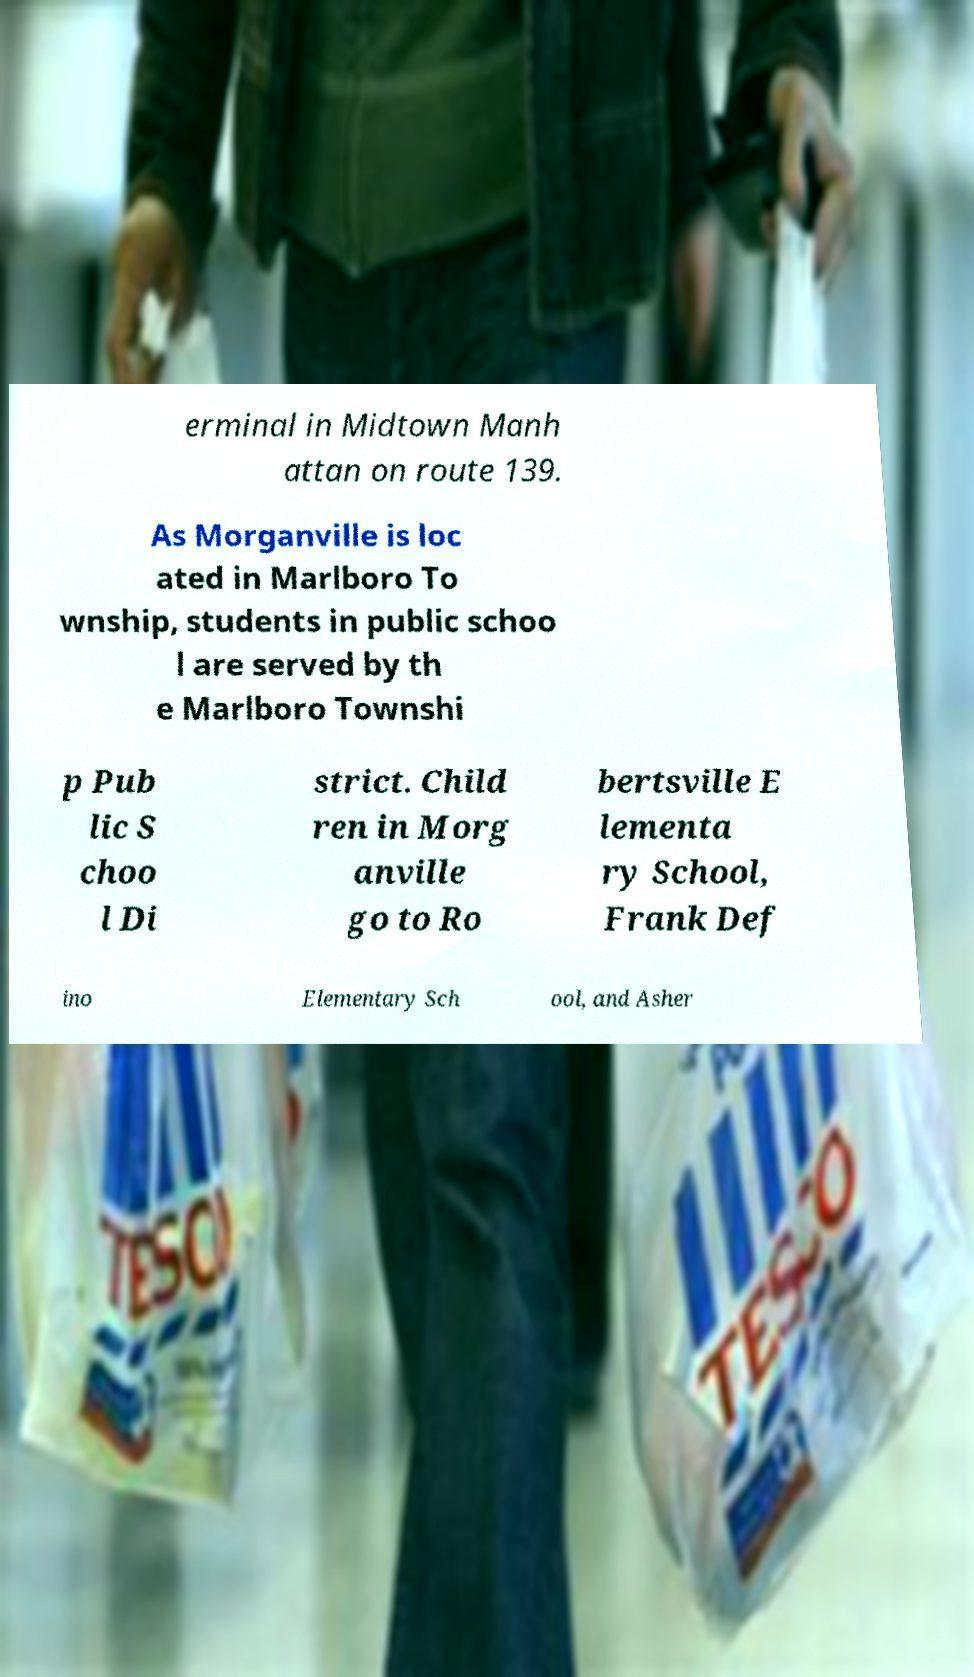Please read and relay the text visible in this image. What does it say? erminal in Midtown Manh attan on route 139. As Morganville is loc ated in Marlboro To wnship, students in public schoo l are served by th e Marlboro Townshi p Pub lic S choo l Di strict. Child ren in Morg anville go to Ro bertsville E lementa ry School, Frank Def ino Elementary Sch ool, and Asher 